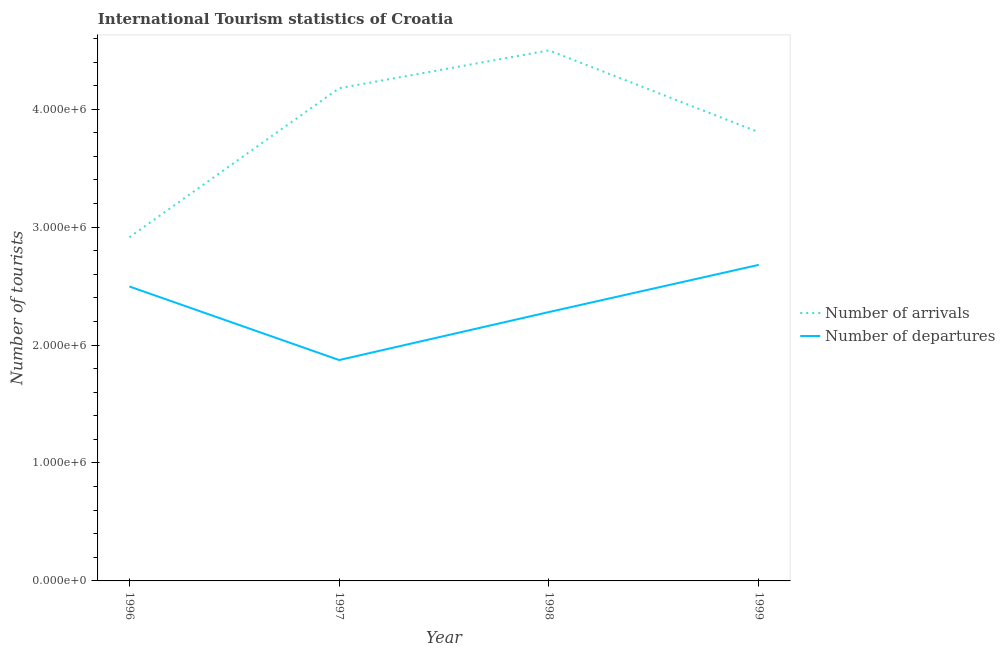Does the line corresponding to number of tourist arrivals intersect with the line corresponding to number of tourist departures?
Give a very brief answer. No. Is the number of lines equal to the number of legend labels?
Offer a very short reply. Yes. What is the number of tourist departures in 1999?
Offer a terse response. 2.68e+06. Across all years, what is the maximum number of tourist arrivals?
Offer a terse response. 4.50e+06. Across all years, what is the minimum number of tourist departures?
Your answer should be compact. 1.87e+06. In which year was the number of tourist arrivals minimum?
Ensure brevity in your answer.  1996. What is the total number of tourist arrivals in the graph?
Make the answer very short. 1.54e+07. What is the difference between the number of tourist arrivals in 1996 and that in 1998?
Provide a succinct answer. -1.58e+06. What is the difference between the number of tourist arrivals in 1997 and the number of tourist departures in 1996?
Provide a short and direct response. 1.68e+06. What is the average number of tourist departures per year?
Offer a terse response. 2.33e+06. In the year 1998, what is the difference between the number of tourist arrivals and number of tourist departures?
Your answer should be very brief. 2.22e+06. In how many years, is the number of tourist departures greater than 600000?
Keep it short and to the point. 4. What is the ratio of the number of tourist departures in 1997 to that in 1999?
Provide a succinct answer. 0.7. Is the number of tourist arrivals in 1996 less than that in 1998?
Provide a succinct answer. Yes. What is the difference between the highest and the second highest number of tourist departures?
Offer a very short reply. 1.83e+05. What is the difference between the highest and the lowest number of tourist arrivals?
Offer a terse response. 1.58e+06. In how many years, is the number of tourist arrivals greater than the average number of tourist arrivals taken over all years?
Offer a very short reply. 2. Is the sum of the number of tourist arrivals in 1998 and 1999 greater than the maximum number of tourist departures across all years?
Keep it short and to the point. Yes. Does the number of tourist departures monotonically increase over the years?
Keep it short and to the point. No. How many lines are there?
Make the answer very short. 2. What is the difference between two consecutive major ticks on the Y-axis?
Your response must be concise. 1.00e+06. Does the graph contain grids?
Ensure brevity in your answer.  No. Where does the legend appear in the graph?
Your answer should be very brief. Center right. How are the legend labels stacked?
Provide a short and direct response. Vertical. What is the title of the graph?
Keep it short and to the point. International Tourism statistics of Croatia. Does "Investment in Transport" appear as one of the legend labels in the graph?
Give a very brief answer. No. What is the label or title of the X-axis?
Offer a terse response. Year. What is the label or title of the Y-axis?
Give a very brief answer. Number of tourists. What is the Number of tourists of Number of arrivals in 1996?
Provide a short and direct response. 2.91e+06. What is the Number of tourists of Number of departures in 1996?
Make the answer very short. 2.50e+06. What is the Number of tourists in Number of arrivals in 1997?
Make the answer very short. 4.18e+06. What is the Number of tourists of Number of departures in 1997?
Give a very brief answer. 1.87e+06. What is the Number of tourists in Number of arrivals in 1998?
Ensure brevity in your answer.  4.50e+06. What is the Number of tourists in Number of departures in 1998?
Make the answer very short. 2.28e+06. What is the Number of tourists of Number of arrivals in 1999?
Keep it short and to the point. 3.80e+06. What is the Number of tourists of Number of departures in 1999?
Make the answer very short. 2.68e+06. Across all years, what is the maximum Number of tourists of Number of arrivals?
Give a very brief answer. 4.50e+06. Across all years, what is the maximum Number of tourists in Number of departures?
Your answer should be compact. 2.68e+06. Across all years, what is the minimum Number of tourists in Number of arrivals?
Ensure brevity in your answer.  2.91e+06. Across all years, what is the minimum Number of tourists in Number of departures?
Provide a short and direct response. 1.87e+06. What is the total Number of tourists of Number of arrivals in the graph?
Offer a very short reply. 1.54e+07. What is the total Number of tourists of Number of departures in the graph?
Provide a succinct answer. 9.33e+06. What is the difference between the Number of tourists of Number of arrivals in 1996 and that in 1997?
Provide a short and direct response. -1.26e+06. What is the difference between the Number of tourists of Number of departures in 1996 and that in 1997?
Give a very brief answer. 6.24e+05. What is the difference between the Number of tourists in Number of arrivals in 1996 and that in 1998?
Your answer should be very brief. -1.58e+06. What is the difference between the Number of tourists in Number of departures in 1996 and that in 1998?
Your answer should be compact. 2.17e+05. What is the difference between the Number of tourists of Number of arrivals in 1996 and that in 1999?
Offer a very short reply. -8.91e+05. What is the difference between the Number of tourists of Number of departures in 1996 and that in 1999?
Offer a very short reply. -1.83e+05. What is the difference between the Number of tourists of Number of arrivals in 1997 and that in 1998?
Offer a very short reply. -3.21e+05. What is the difference between the Number of tourists in Number of departures in 1997 and that in 1998?
Offer a terse response. -4.07e+05. What is the difference between the Number of tourists of Number of arrivals in 1997 and that in 1999?
Keep it short and to the point. 3.73e+05. What is the difference between the Number of tourists in Number of departures in 1997 and that in 1999?
Keep it short and to the point. -8.07e+05. What is the difference between the Number of tourists of Number of arrivals in 1998 and that in 1999?
Keep it short and to the point. 6.94e+05. What is the difference between the Number of tourists of Number of departures in 1998 and that in 1999?
Offer a terse response. -4.00e+05. What is the difference between the Number of tourists of Number of arrivals in 1996 and the Number of tourists of Number of departures in 1997?
Provide a succinct answer. 1.04e+06. What is the difference between the Number of tourists in Number of arrivals in 1996 and the Number of tourists in Number of departures in 1998?
Ensure brevity in your answer.  6.34e+05. What is the difference between the Number of tourists of Number of arrivals in 1996 and the Number of tourists of Number of departures in 1999?
Give a very brief answer. 2.34e+05. What is the difference between the Number of tourists of Number of arrivals in 1997 and the Number of tourists of Number of departures in 1998?
Offer a very short reply. 1.90e+06. What is the difference between the Number of tourists in Number of arrivals in 1997 and the Number of tourists in Number of departures in 1999?
Provide a succinct answer. 1.50e+06. What is the difference between the Number of tourists in Number of arrivals in 1998 and the Number of tourists in Number of departures in 1999?
Provide a succinct answer. 1.82e+06. What is the average Number of tourists of Number of arrivals per year?
Give a very brief answer. 3.85e+06. What is the average Number of tourists in Number of departures per year?
Your answer should be compact. 2.33e+06. In the year 1996, what is the difference between the Number of tourists of Number of arrivals and Number of tourists of Number of departures?
Provide a short and direct response. 4.17e+05. In the year 1997, what is the difference between the Number of tourists of Number of arrivals and Number of tourists of Number of departures?
Provide a short and direct response. 2.30e+06. In the year 1998, what is the difference between the Number of tourists of Number of arrivals and Number of tourists of Number of departures?
Provide a short and direct response. 2.22e+06. In the year 1999, what is the difference between the Number of tourists of Number of arrivals and Number of tourists of Number of departures?
Make the answer very short. 1.12e+06. What is the ratio of the Number of tourists in Number of arrivals in 1996 to that in 1997?
Give a very brief answer. 0.7. What is the ratio of the Number of tourists of Number of departures in 1996 to that in 1997?
Offer a terse response. 1.33. What is the ratio of the Number of tourists of Number of arrivals in 1996 to that in 1998?
Keep it short and to the point. 0.65. What is the ratio of the Number of tourists of Number of departures in 1996 to that in 1998?
Give a very brief answer. 1.1. What is the ratio of the Number of tourists in Number of arrivals in 1996 to that in 1999?
Keep it short and to the point. 0.77. What is the ratio of the Number of tourists in Number of departures in 1996 to that in 1999?
Your response must be concise. 0.93. What is the ratio of the Number of tourists in Number of arrivals in 1997 to that in 1998?
Ensure brevity in your answer.  0.93. What is the ratio of the Number of tourists of Number of departures in 1997 to that in 1998?
Provide a short and direct response. 0.82. What is the ratio of the Number of tourists in Number of arrivals in 1997 to that in 1999?
Provide a succinct answer. 1.1. What is the ratio of the Number of tourists in Number of departures in 1997 to that in 1999?
Provide a succinct answer. 0.7. What is the ratio of the Number of tourists of Number of arrivals in 1998 to that in 1999?
Offer a very short reply. 1.18. What is the ratio of the Number of tourists of Number of departures in 1998 to that in 1999?
Provide a succinct answer. 0.85. What is the difference between the highest and the second highest Number of tourists in Number of arrivals?
Make the answer very short. 3.21e+05. What is the difference between the highest and the second highest Number of tourists of Number of departures?
Your answer should be very brief. 1.83e+05. What is the difference between the highest and the lowest Number of tourists in Number of arrivals?
Provide a succinct answer. 1.58e+06. What is the difference between the highest and the lowest Number of tourists in Number of departures?
Give a very brief answer. 8.07e+05. 